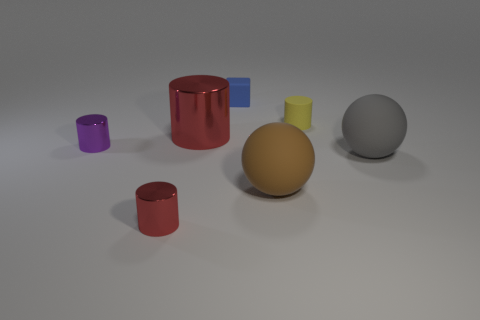Subtract 1 cylinders. How many cylinders are left? 3 Subtract all green cylinders. Subtract all red balls. How many cylinders are left? 4 Add 2 gray cylinders. How many objects exist? 9 Subtract all cubes. How many objects are left? 6 Subtract 0 blue spheres. How many objects are left? 7 Subtract all tiny yellow matte objects. Subtract all cyan blocks. How many objects are left? 6 Add 4 blue rubber blocks. How many blue rubber blocks are left? 5 Add 5 big gray rubber spheres. How many big gray rubber spheres exist? 6 